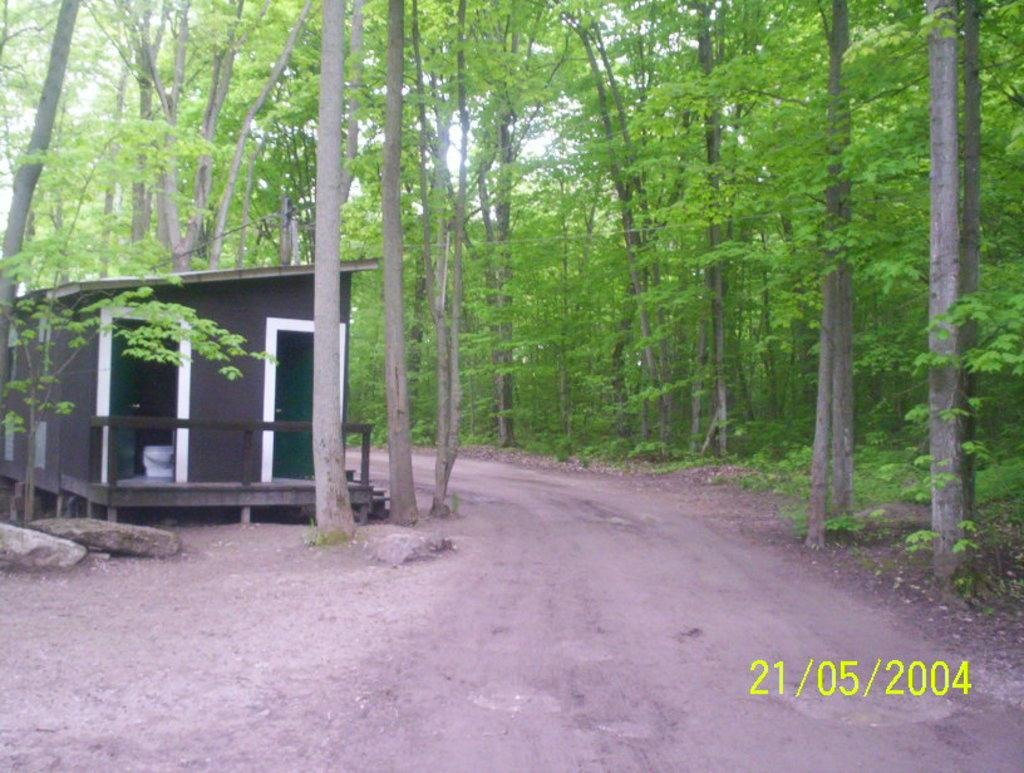What type of structure is present in the image? There is a house in the image. What features can be observed on the house? The house has a roof and doors. What type of material is present in the image? There are stones in the image. What type of pathway is visible in the image? There is a pathway in the image. What type of vegetation is present in the image? There is a group of trees in the image, and the bark of the trees is visible. What is visible in the sky in the image? The sky is visible in the image, and it appears cloudy. What type of corn can be seen growing near the house in the image? There is no corn present in the image; it features a house, a pathway, a group of trees, and stones. How many apples can be seen hanging from the trees in the image? There are no apples present in the image; only trees with visible bark are depicted. 